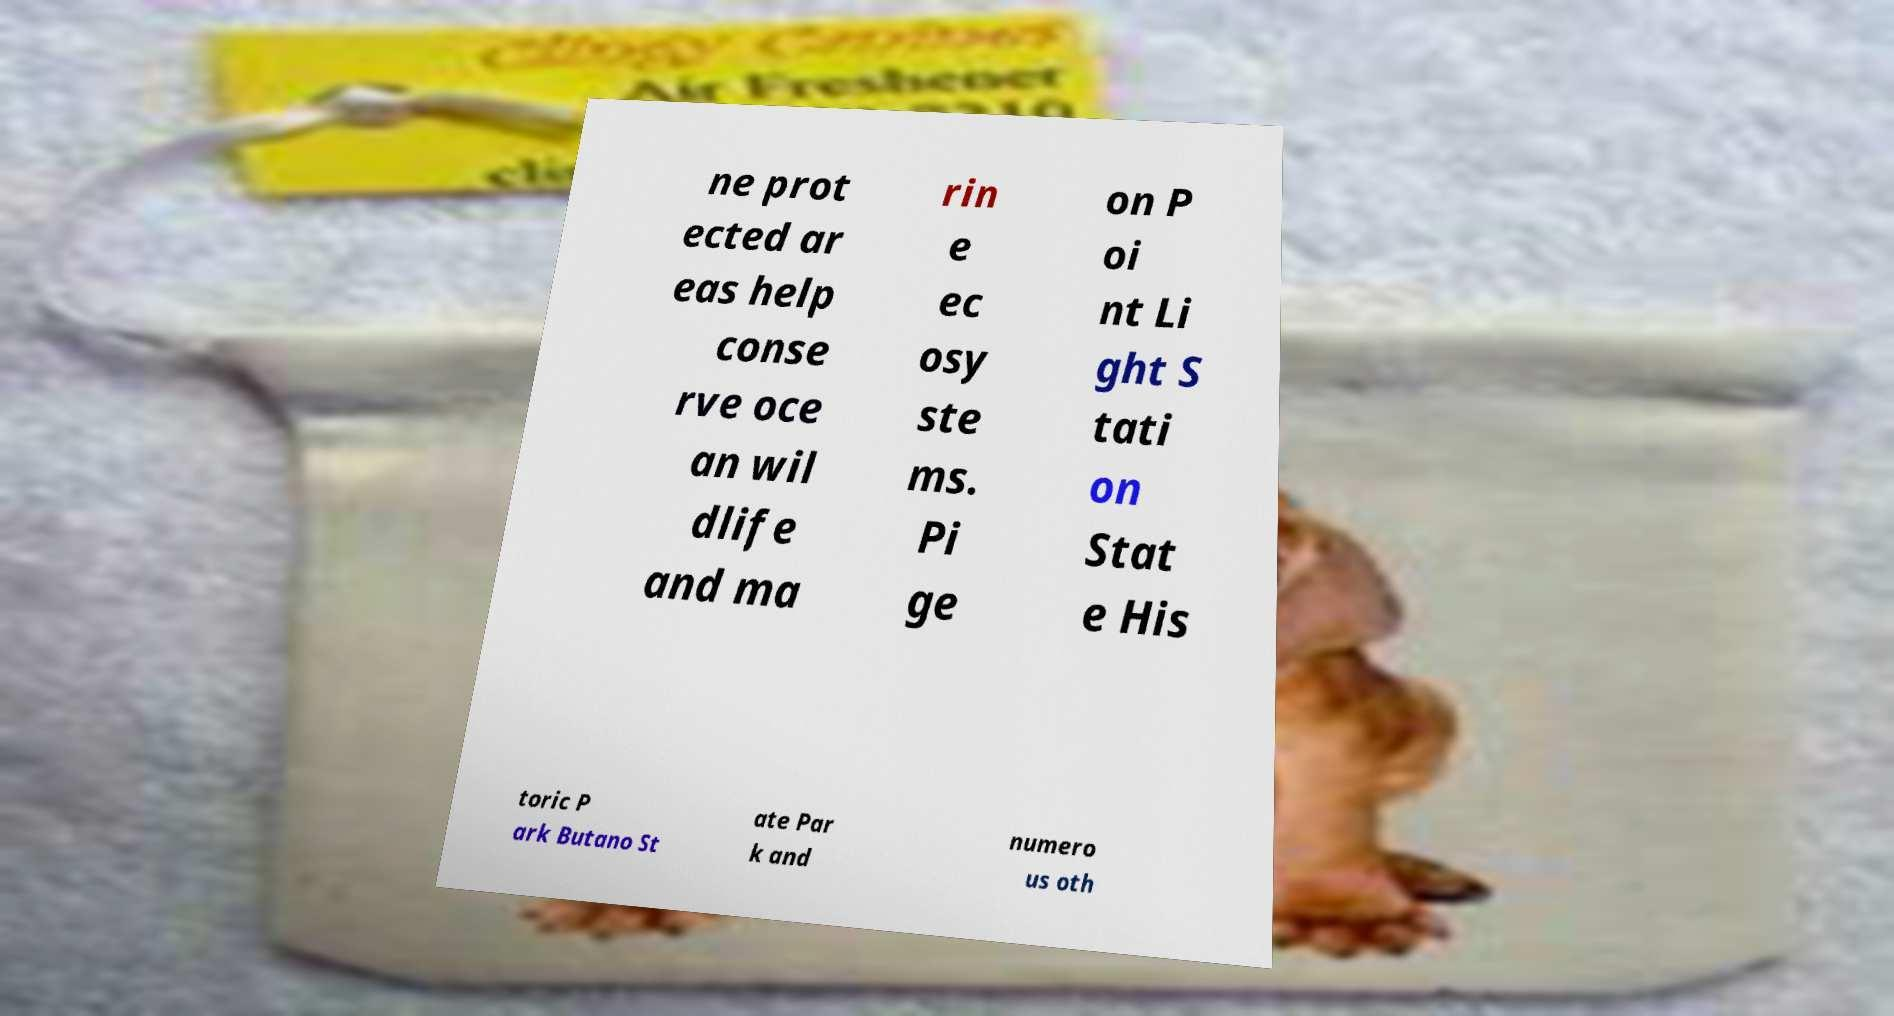Can you read and provide the text displayed in the image?This photo seems to have some interesting text. Can you extract and type it out for me? ne prot ected ar eas help conse rve oce an wil dlife and ma rin e ec osy ste ms. Pi ge on P oi nt Li ght S tati on Stat e His toric P ark Butano St ate Par k and numero us oth 